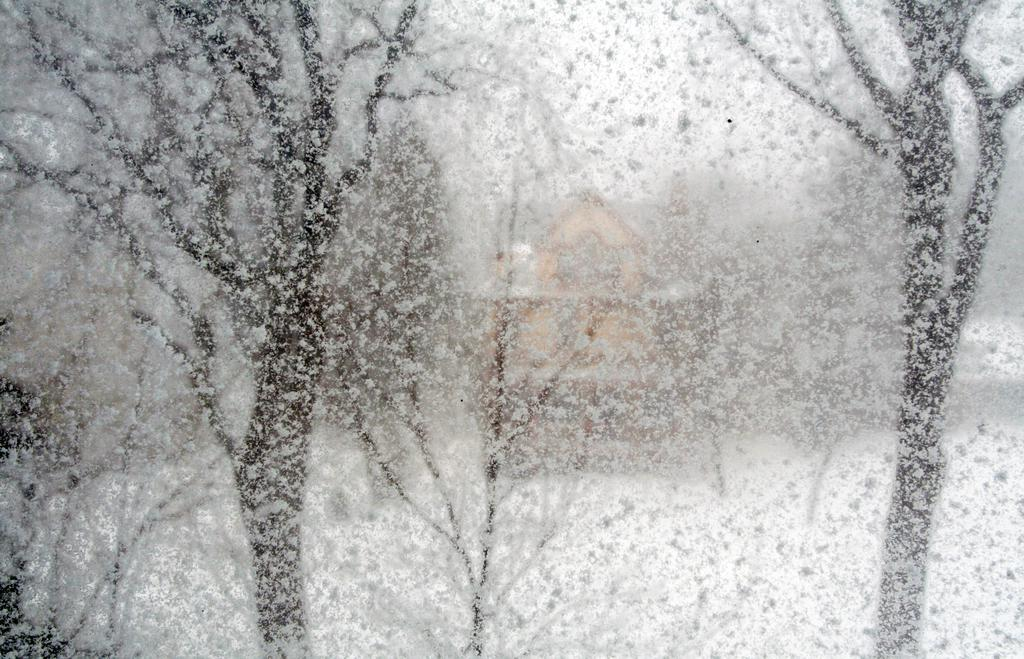What is happening in the image? It is snowing in the image. What can be seen in the foreground of the image? There are trees in the foreground of the image. What is visible in the background of the image? There is a building in the background of the image. What type of tail can be seen on the fowl in the image? There is no fowl present in the image, so there is no tail to be seen. 